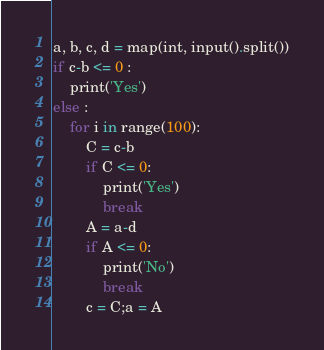Convert code to text. <code><loc_0><loc_0><loc_500><loc_500><_Python_>a, b, c, d = map(int, input().split())
if c-b <= 0 :
    print('Yes')
else :
    for i in range(100):
        C = c-b 
        if C <= 0:
            print('Yes')
            break
        A = a-d 
        if A <= 0:
            print('No')
            break
        c = C;a = A</code> 